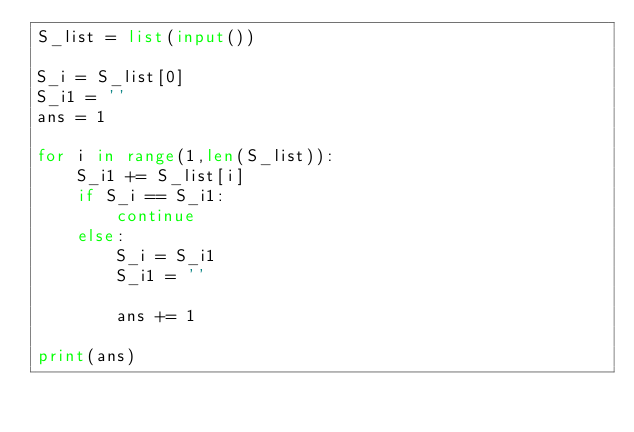Convert code to text. <code><loc_0><loc_0><loc_500><loc_500><_Python_>S_list = list(input())

S_i = S_list[0]
S_i1 = ''
ans = 1

for i in range(1,len(S_list)):
    S_i1 += S_list[i]
    if S_i == S_i1:
        continue
    else:
        S_i = S_i1
        S_i1 = ''
        
        ans += 1
        
print(ans)</code> 